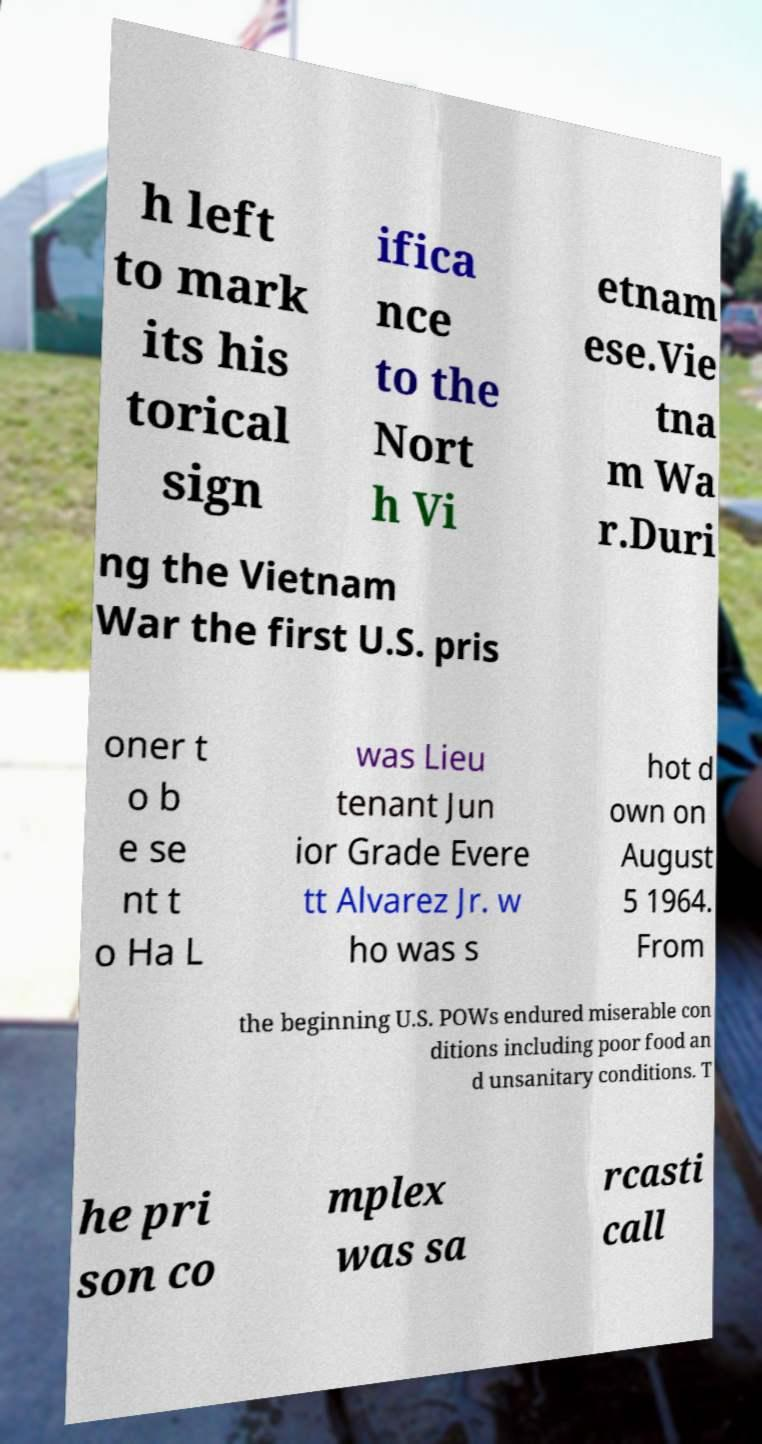What messages or text are displayed in this image? I need them in a readable, typed format. h left to mark its his torical sign ifica nce to the Nort h Vi etnam ese.Vie tna m Wa r.Duri ng the Vietnam War the first U.S. pris oner t o b e se nt t o Ha L was Lieu tenant Jun ior Grade Evere tt Alvarez Jr. w ho was s hot d own on August 5 1964. From the beginning U.S. POWs endured miserable con ditions including poor food an d unsanitary conditions. T he pri son co mplex was sa rcasti call 